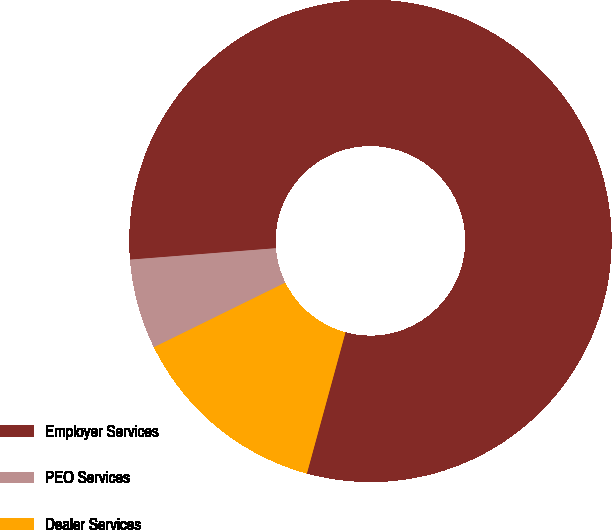<chart> <loc_0><loc_0><loc_500><loc_500><pie_chart><fcel>Employer Services<fcel>PEO Services<fcel>Dealer Services<nl><fcel>80.49%<fcel>6.03%<fcel>13.48%<nl></chart> 